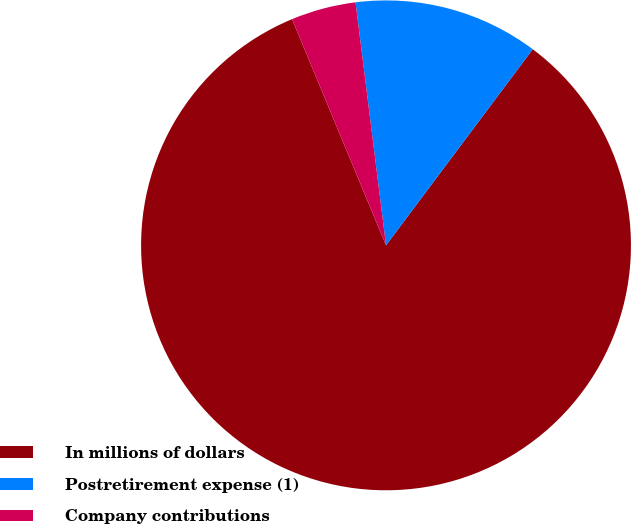<chart> <loc_0><loc_0><loc_500><loc_500><pie_chart><fcel>In millions of dollars<fcel>Postretirement expense (1)<fcel>Company contributions<nl><fcel>83.51%<fcel>12.21%<fcel>4.28%<nl></chart> 